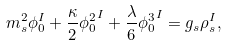<formula> <loc_0><loc_0><loc_500><loc_500>m _ { s } ^ { 2 } \phi _ { 0 } ^ { I } + \frac { \kappa } { 2 } { \phi _ { 0 } ^ { 2 } } ^ { I } + \frac { \lambda } { 6 } { \phi _ { 0 } ^ { 3 } } ^ { I } = g _ { s } \rho _ { s } ^ { I } ,</formula> 